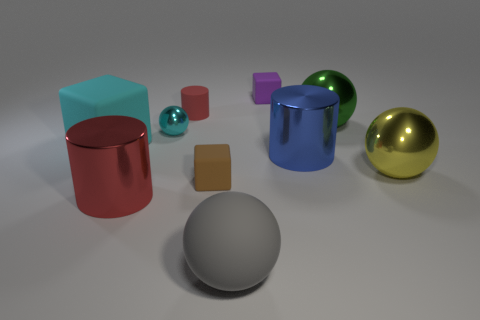Subtract all gray matte balls. How many balls are left? 3 Subtract all cyan blocks. How many blocks are left? 2 Subtract 3 cylinders. How many cylinders are left? 0 Subtract 0 brown cylinders. How many objects are left? 10 Subtract all cylinders. How many objects are left? 7 Subtract all red cylinders. Subtract all blue spheres. How many cylinders are left? 1 Subtract all purple balls. How many blue cylinders are left? 1 Subtract all tiny metallic balls. Subtract all yellow metal objects. How many objects are left? 8 Add 6 cyan objects. How many cyan objects are left? 8 Add 9 green metal objects. How many green metal objects exist? 10 